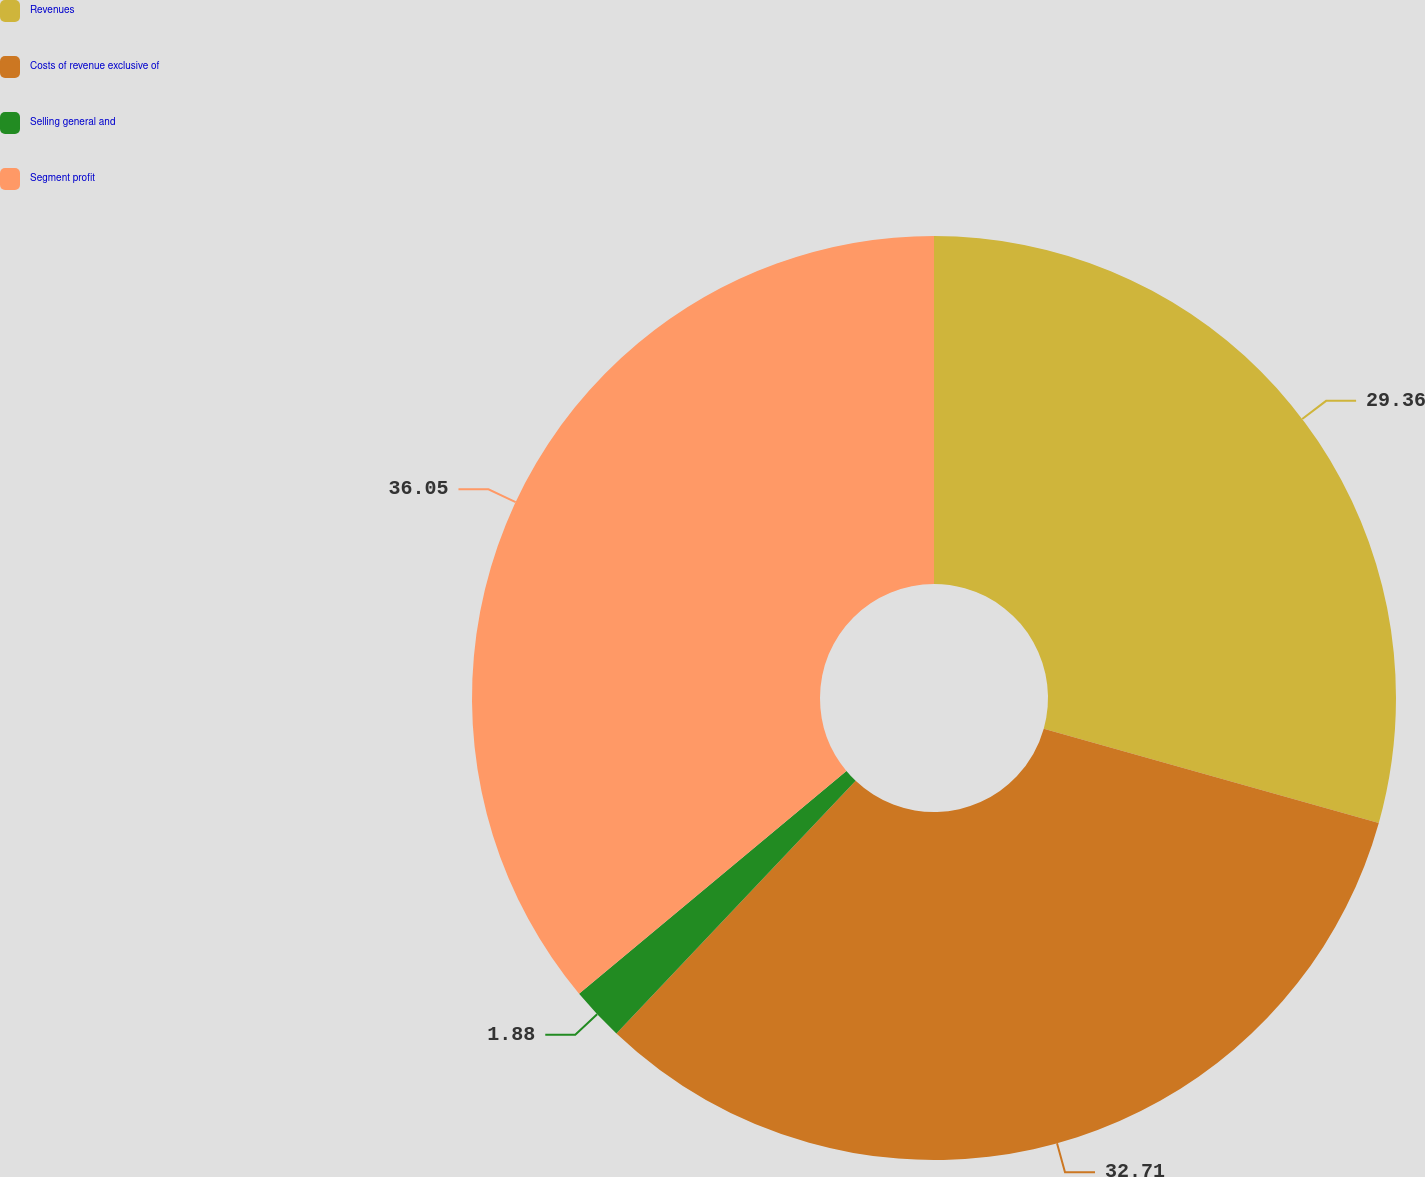<chart> <loc_0><loc_0><loc_500><loc_500><pie_chart><fcel>Revenues<fcel>Costs of revenue exclusive of<fcel>Selling general and<fcel>Segment profit<nl><fcel>29.36%<fcel>32.71%<fcel>1.88%<fcel>36.06%<nl></chart> 